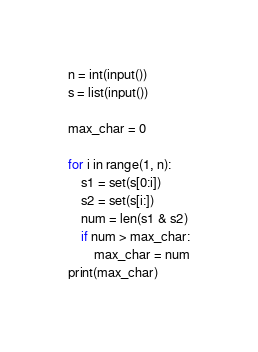<code> <loc_0><loc_0><loc_500><loc_500><_Python_>n = int(input())
s = list(input())

max_char = 0

for i in range(1, n):
    s1 = set(s[0:i])
    s2 = set(s[i:])
    num = len(s1 & s2)
    if num > max_char:
        max_char = num
print(max_char)</code> 